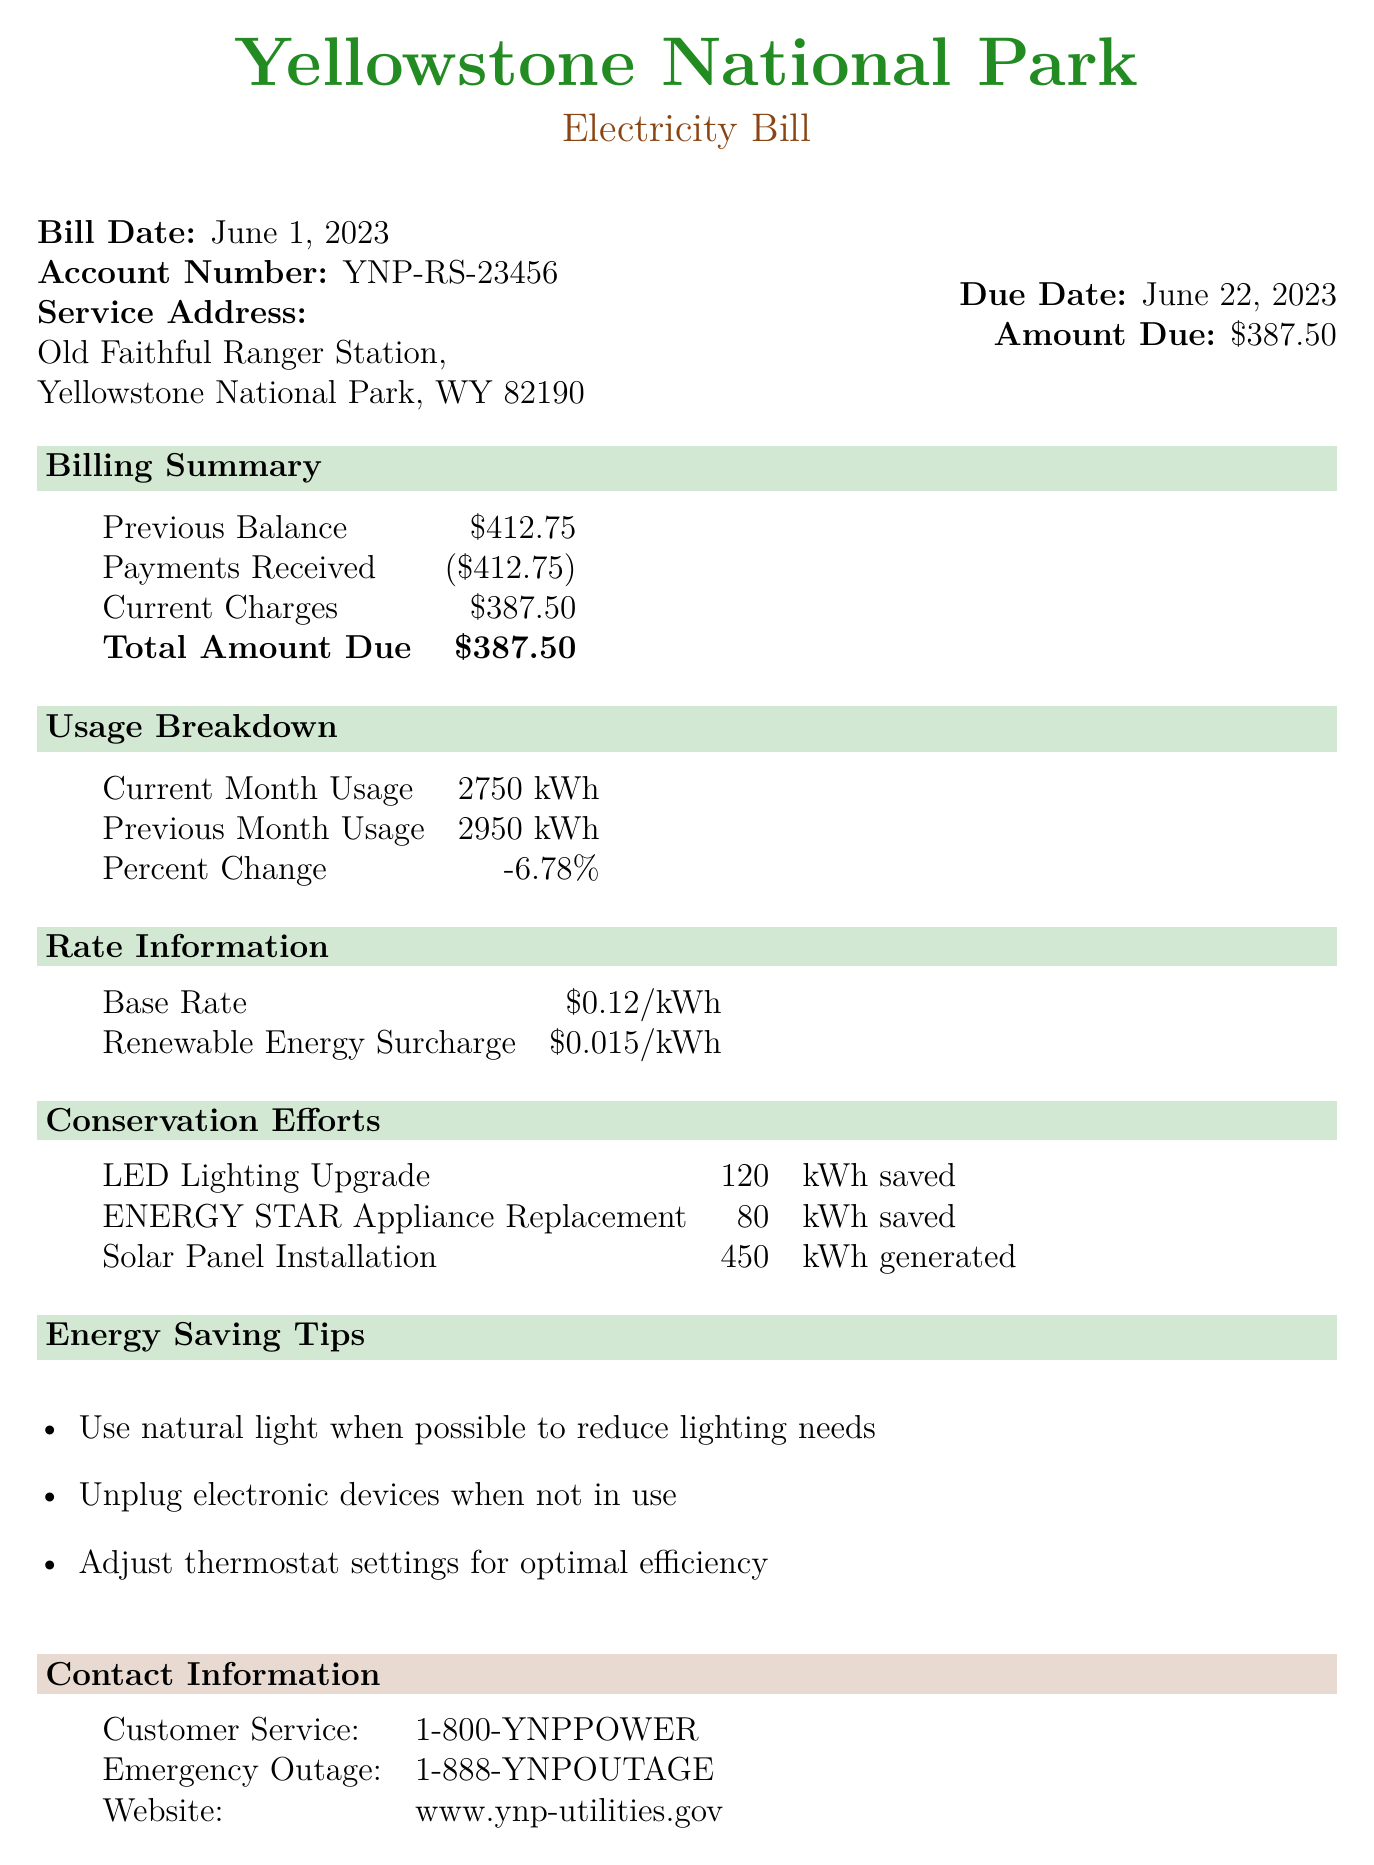What is the bill date? The bill date is mentioned at the beginning of the document.
Answer: June 1, 2023 What is the service address? The service address is specified in the account information section.
Answer: Old Faithful Ranger Station, Yellowstone National Park, WY 82190 What is the amount due? The amount due is displayed on the right side of the bill summary.
Answer: $387.50 What was the previous month's usage? The previous month usage is noted in the usage breakdown section.
Answer: 2950 kWh What is the percentage change in usage compared to the previous month? The percentage change is calculated from the usage breakdown.
Answer: -6.78% What is the total amount due after payments? The total amount due is summarized at the end of the billing summary section.
Answer: $387.50 How much energy was saved through the LED lighting upgrade? The energy savings from the LED lighting upgrade is detailed in the conservation efforts section.
Answer: 120 kWh saved What is the renewable energy surcharge rate? The surcharge rate is listed under rate information in the document.
Answer: $0.015/kWh What are two energy-saving tips mentioned? Energy-saving tips are provided at the end of the document.
Answer: Use natural light when possible, Unplug electronic devices when not in use 